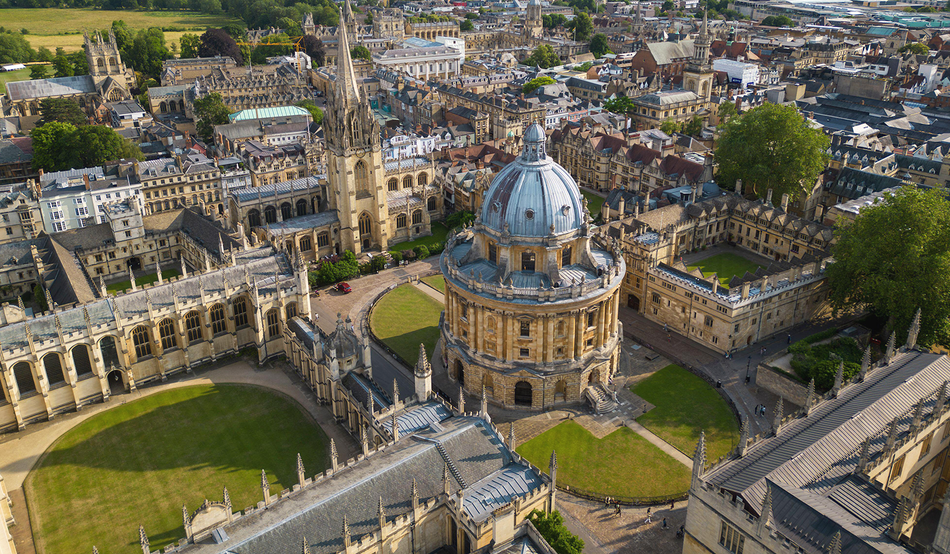Imagine the Radcliffe Camera turning into a giant clock tower. How would that look and function? Imagine the Radcliffe Camera transformed into a colossal clock tower, with its grand dome morphing into an enormous clock face. Its architectural elements would blend seamlessly with intricate gears and mechanisms visible through transparent sections of the stonework. The clock hands could be styled as elegant spires, consistently ticking away the minutes and hours. This transformation would create a mesmerizing fusion of history and innovation, turning the Radcliffe Camera into a central timepiece for the university, symbolizing the timeless pursuit of knowledge and the preciousness of academic time. 